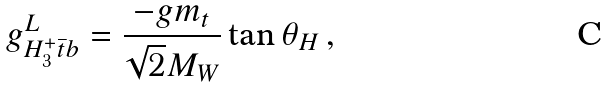Convert formula to latex. <formula><loc_0><loc_0><loc_500><loc_500>g _ { H _ { 3 } ^ { + } \bar { t } b } ^ { L } = \frac { - g m _ { t } } { \sqrt { 2 } M _ { W } } \tan \theta _ { H } \, ,</formula> 